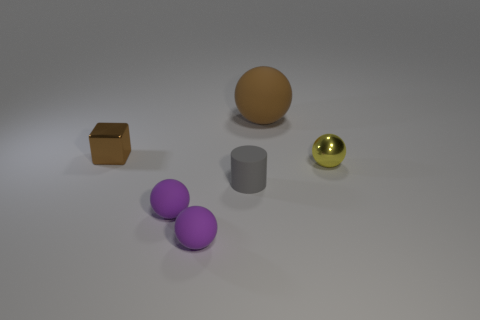Subtract all metal balls. How many balls are left? 3 Add 3 red spheres. How many objects exist? 9 Subtract all brown balls. How many balls are left? 3 Subtract all cyan cylinders. How many purple spheres are left? 2 Subtract all balls. How many objects are left? 2 Subtract 1 cubes. How many cubes are left? 0 Subtract all gray objects. Subtract all gray rubber cylinders. How many objects are left? 4 Add 3 brown spheres. How many brown spheres are left? 4 Add 3 small gray rubber things. How many small gray rubber things exist? 4 Subtract 0 cyan spheres. How many objects are left? 6 